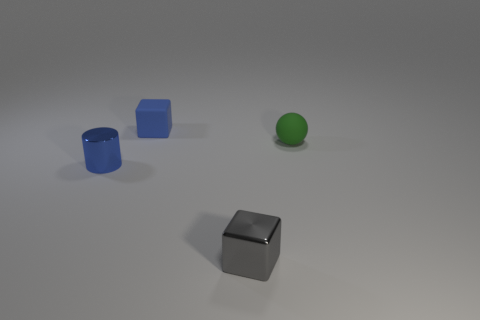Is the material of the tiny thing that is in front of the small blue metallic cylinder the same as the block that is behind the gray thing?
Your response must be concise. No. What number of small objects are both to the left of the small metal cube and to the right of the tiny gray thing?
Give a very brief answer. 0. Are there any other green matte objects that have the same shape as the green rubber thing?
Give a very brief answer. No. The green matte thing that is the same size as the rubber block is what shape?
Provide a succinct answer. Sphere. Are there an equal number of small blue metal cylinders in front of the blue metallic thing and small gray things behind the small blue matte block?
Provide a succinct answer. Yes. There is a blue thing left of the tiny cube behind the green thing; what size is it?
Provide a succinct answer. Small. Is there another blue block that has the same size as the blue matte block?
Provide a short and direct response. No. What is the color of the cylinder that is the same material as the small gray cube?
Give a very brief answer. Blue. Are there fewer gray metal things than small red metal balls?
Offer a very short reply. No. The tiny thing that is in front of the small sphere and on the left side of the small gray metal block is made of what material?
Offer a terse response. Metal. 